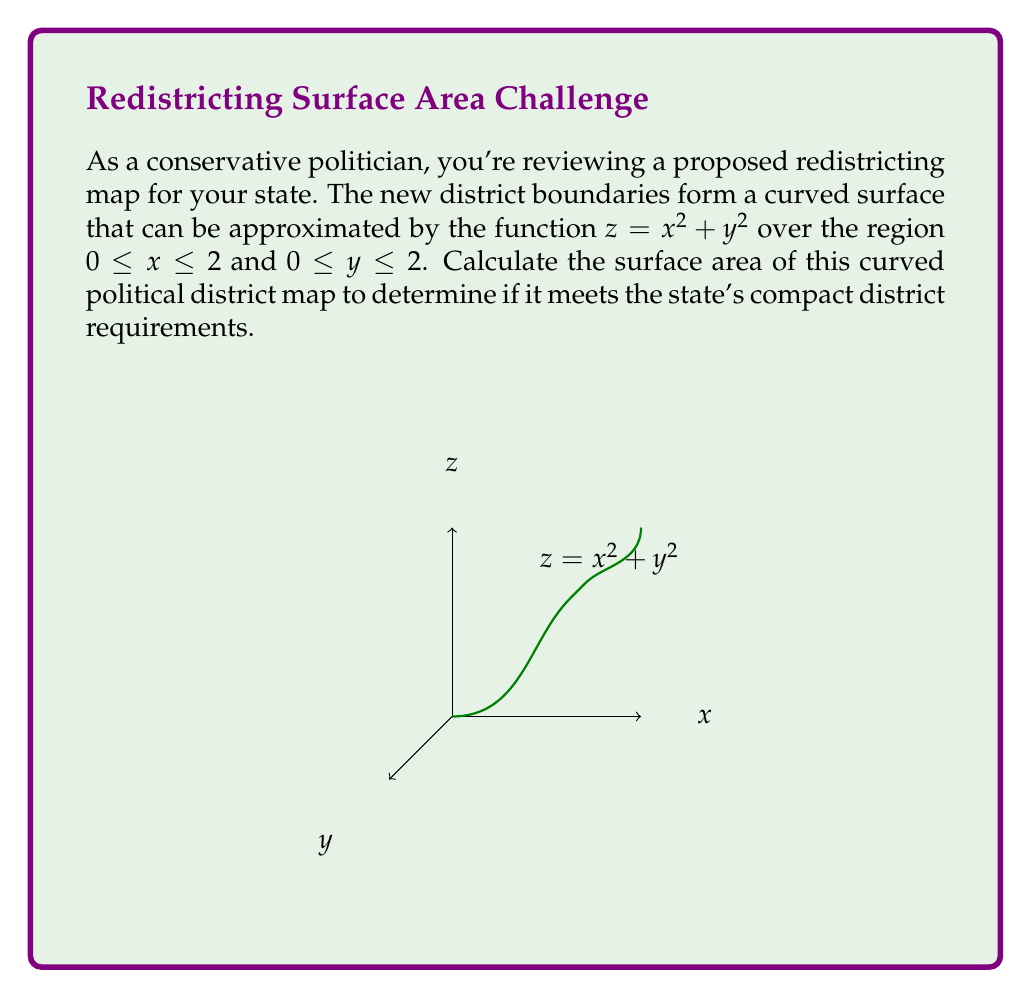Teach me how to tackle this problem. To calculate the surface area of the curved political district map, we need to use the surface area formula for a parametric surface:

$$ A = \iint_R \sqrt{1 + \left(\frac{\partial z}{\partial x}\right)^2 + \left(\frac{\partial z}{\partial y}\right)^2} \, dA $$

Where $R$ is the region of integration, and $z = f(x,y) = x^2 + y^2$.

Step 1: Calculate the partial derivatives:
$\frac{\partial z}{\partial x} = 2x$
$\frac{\partial z}{\partial y} = 2y$

Step 2: Substitute these into the surface area formula:
$$ A = \int_0^2 \int_0^2 \sqrt{1 + (2x)^2 + (2y)^2} \, dy \, dx $$

Step 3: Simplify the integrand:
$$ A = \int_0^2 \int_0^2 \sqrt{1 + 4x^2 + 4y^2} \, dy \, dx $$

Step 4: This integral is difficult to evaluate analytically, so we'll use numerical integration. Using a computer algebra system or numerical integration tool, we can approximate the result:

$$ A \approx 11.4628 $$

Step 5: The units for this calculation are square units (e.g., square miles or square kilometers, depending on the scale of the map).
Answer: $11.4628$ square units 